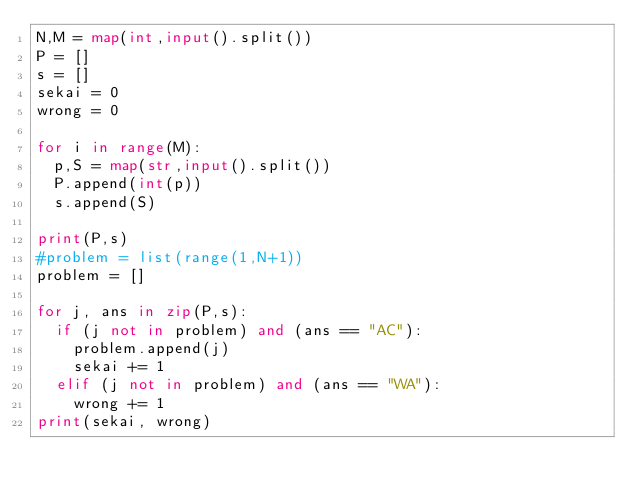Convert code to text. <code><loc_0><loc_0><loc_500><loc_500><_Python_>N,M = map(int,input().split())
P = []
s = []
sekai = 0
wrong = 0

for i in range(M):
  p,S = map(str,input().split())
  P.append(int(p))
  s.append(S)

print(P,s)
#problem = list(range(1,N+1))
problem = []

for j, ans in zip(P,s):
  if (j not in problem) and (ans == "AC"):
    problem.append(j)
    sekai += 1
  elif (j not in problem) and (ans == "WA"):
    wrong += 1
print(sekai, wrong)</code> 